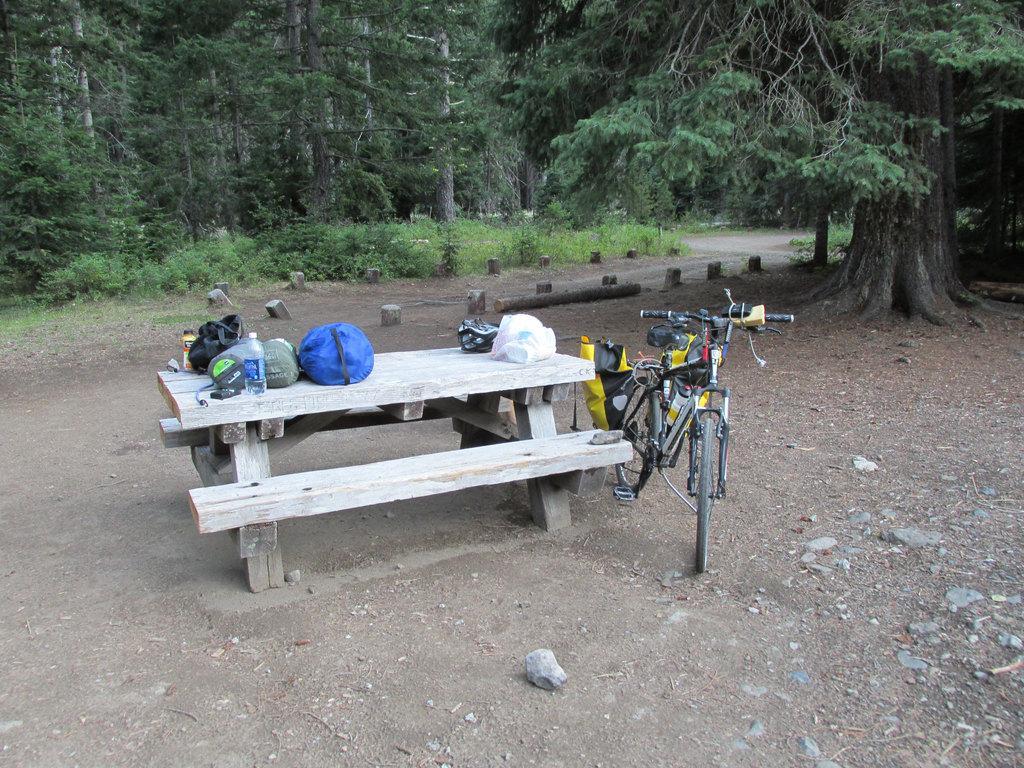Can you describe this image briefly? In this picture there is a bicycle which is parked near to the bench and table. On the table I can see the plastic covers, bags, purse and water bottle. In the background I can see many trees, plants and grass. At the bottom I can see some stones. 